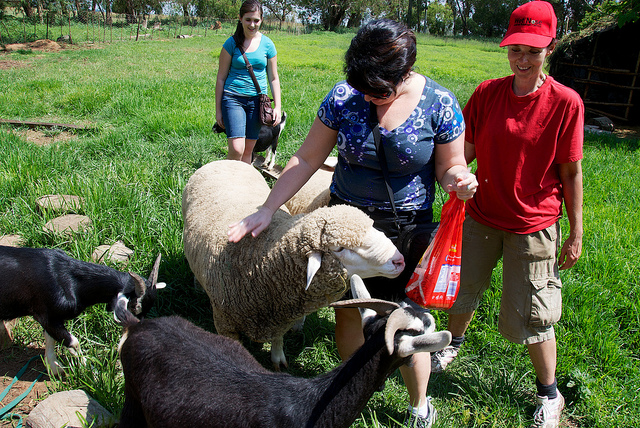What's the color of the cap of the person on the right side of the image? The person on the right side of the image is wearing a red cap, which adds a bright splash of color against the green pasture background. 